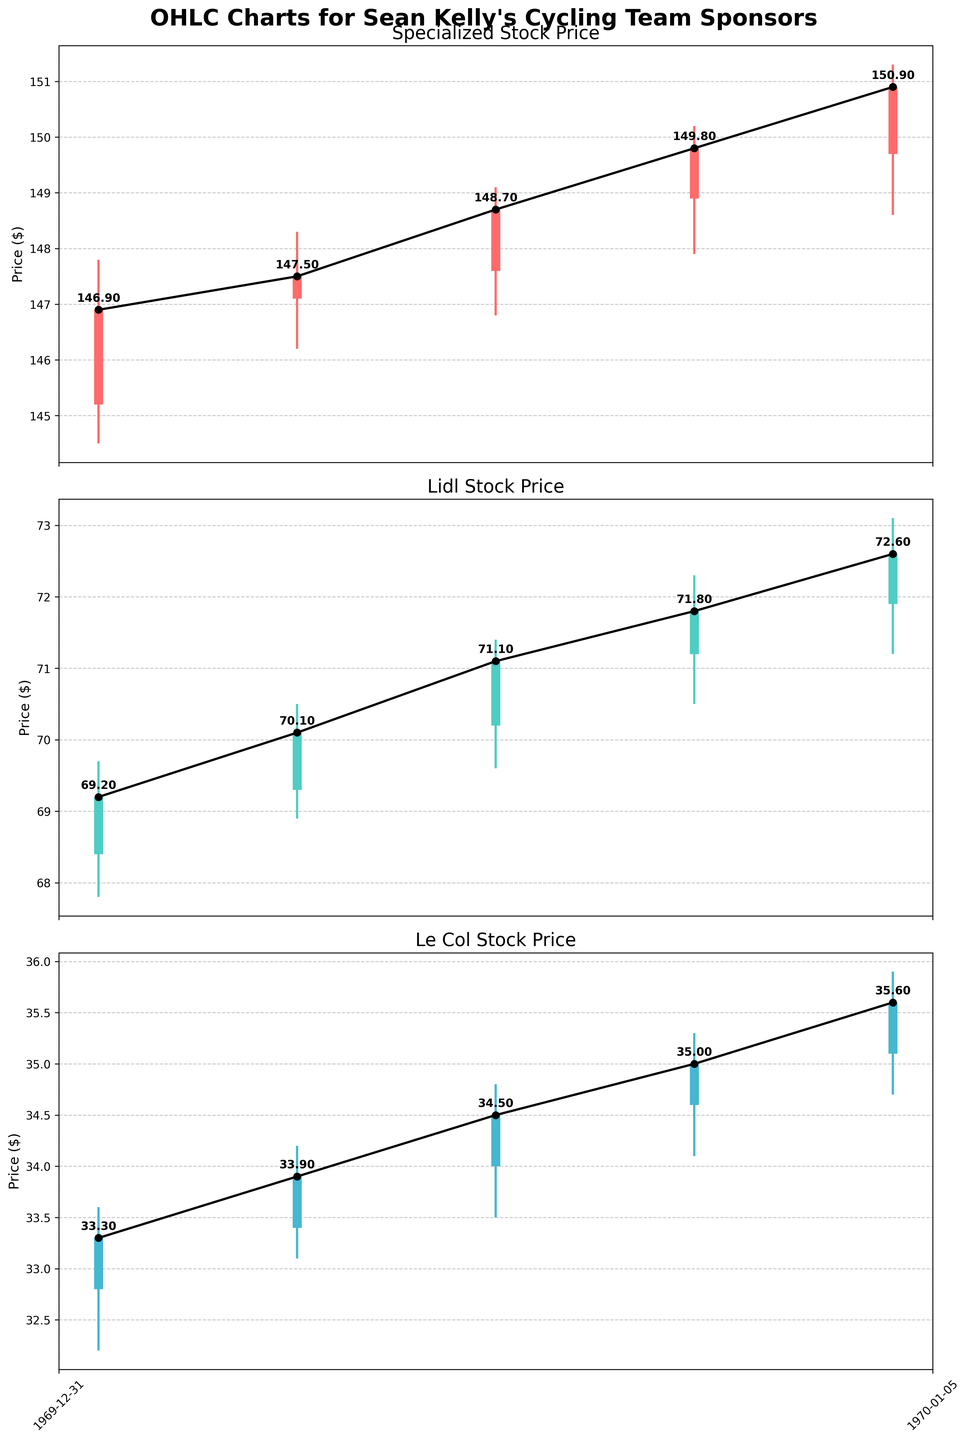What are the companies whose stock prices are displayed in the figure? The title of the figure mentions it depicts stock prices for Sean Kelly's cycling team sponsors. Names of the companies can be identified from the subplots' titles.
Answer: Specialized, Lidl, Le Col What is the trend of Specialized's closing stock prices over the presented dates? By observing the plot for Specialized, the closing prices are incrementally increasing from one day to the next. Starting at $146.90 on May 1st to $150.90 on May 5th.
Answer: Increasing What was the highest closing price for Le Col during the given period? By looking at the Le Col plot and the annotations on each day, the highest closing price is on May 5th at $35.60.
Answer: $35.60 On which date did Lidl's stock experience its highest daily high? The plot for Lidl shows daily high prices, with the highest value on May 5th reaching $73.10.
Answer: May 5th Compare the closing stock price of Specialized on May 1st and May 5th, and find the percentage change. The closing price on May 1st was $146.90 and on May 5th was $150.90. The percentage change can be calculated as \(\frac{150.90 - 146.90}{146.90} \times 100\).
Answer: 2.72% What is the average closing price for Lidl during the specified period? The closing prices for Lidl are $69.20, $70.10, $71.10, $71.80, and $72.60. The average is \(\frac{69.20 + 70.10 + 71.10 + 71.80 + 72.60}{5}\).
Answer: $71.36 Which company had the smallest range between its highest and lowest stock prices over the period? For each company, subtract the lowest low from the highest high: Specialized: $151.30 - $144.50 = $6.80, Lidl: $73.10 - $67.80 = $5.30, Le Col: $35.90 - $32.20 = $3.70. Le Col had the smallest range.
Answer: Le Col On which date did Le Col experience the greatest difference between its opening and closing prices? By checking the Le Col plot, we calculate the differences: May 1st: $33.30 - $32.80 = $0.50, May 2nd: $33.90 - $33.40 = $0.50, May 3rd: $34.50 - $34.00 = $0.50, May 4th: $35.00 - $34.60 = $0.40, May 5th: $35.60 - $35.10 = $0.50. Multiple dates have the largest difference of $0.50.
Answer: May 1, May 2, May 3, May 5 What was the closing price of Specialized on May 3rd? Check the closing price annotations on the Specialized plot for May 3rd which shows $148.70.
Answer: $148.70 